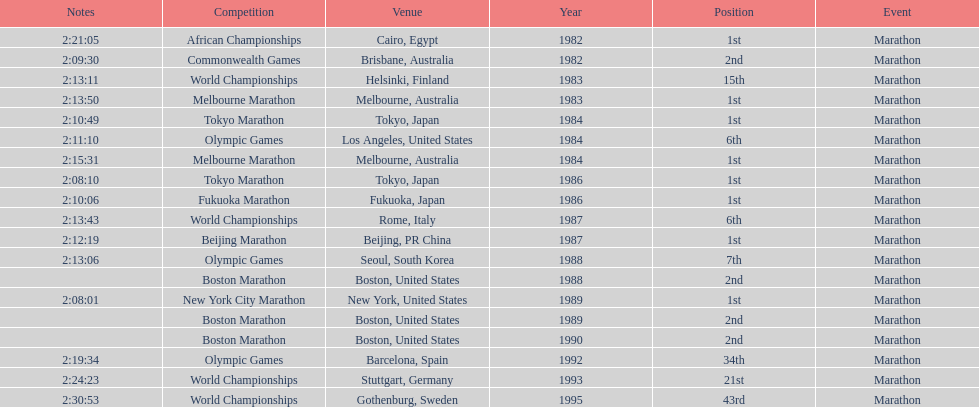Which competitive event is featured the most in this chart? World Championships. 